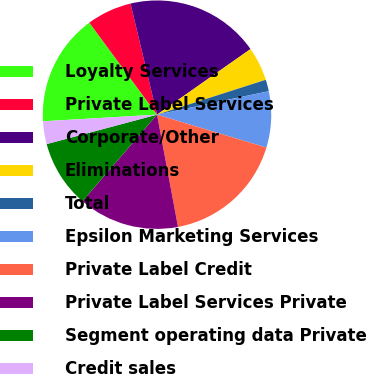<chart> <loc_0><loc_0><loc_500><loc_500><pie_chart><fcel>Loyalty Services<fcel>Private Label Services<fcel>Corporate/Other<fcel>Eliminations<fcel>Total<fcel>Epsilon Marketing Services<fcel>Private Label Credit<fcel>Private Label Services Private<fcel>Segment operating data Private<fcel>Credit sales<nl><fcel>15.83%<fcel>6.37%<fcel>18.99%<fcel>4.8%<fcel>1.64%<fcel>7.95%<fcel>17.41%<fcel>14.26%<fcel>9.53%<fcel>3.22%<nl></chart> 